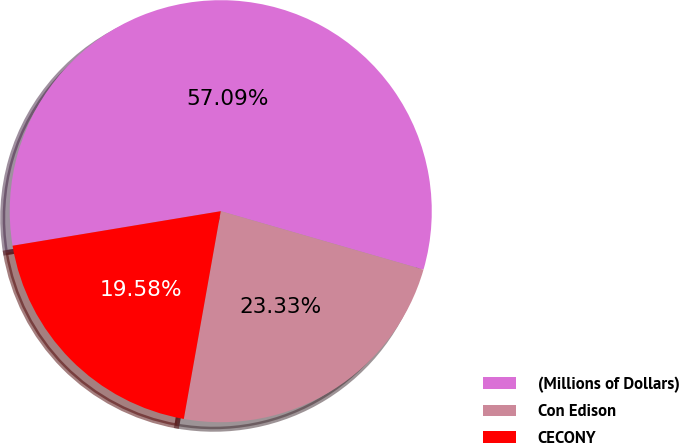Convert chart to OTSL. <chart><loc_0><loc_0><loc_500><loc_500><pie_chart><fcel>(Millions of Dollars)<fcel>Con Edison<fcel>CECONY<nl><fcel>57.08%<fcel>23.33%<fcel>19.58%<nl></chart> 